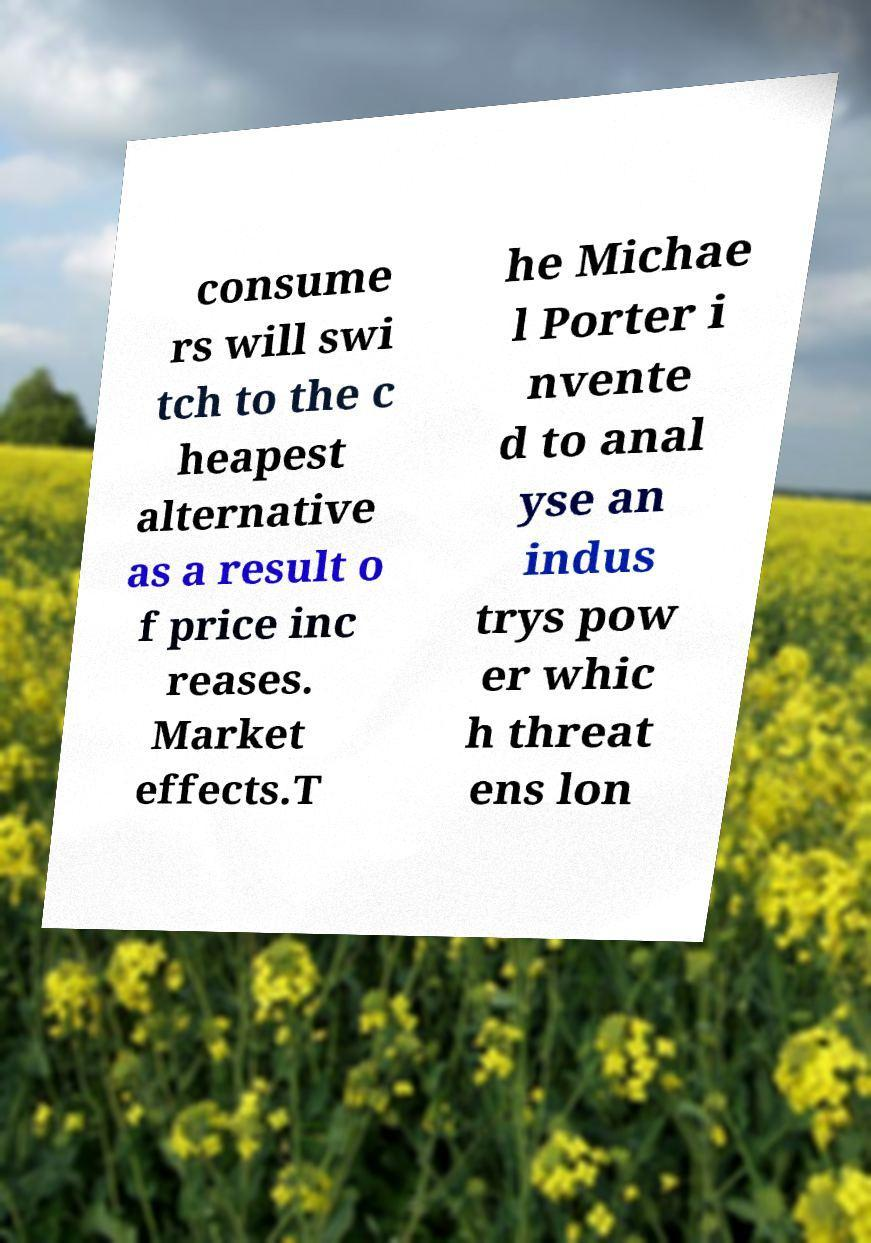I need the written content from this picture converted into text. Can you do that? consume rs will swi tch to the c heapest alternative as a result o f price inc reases. Market effects.T he Michae l Porter i nvente d to anal yse an indus trys pow er whic h threat ens lon 